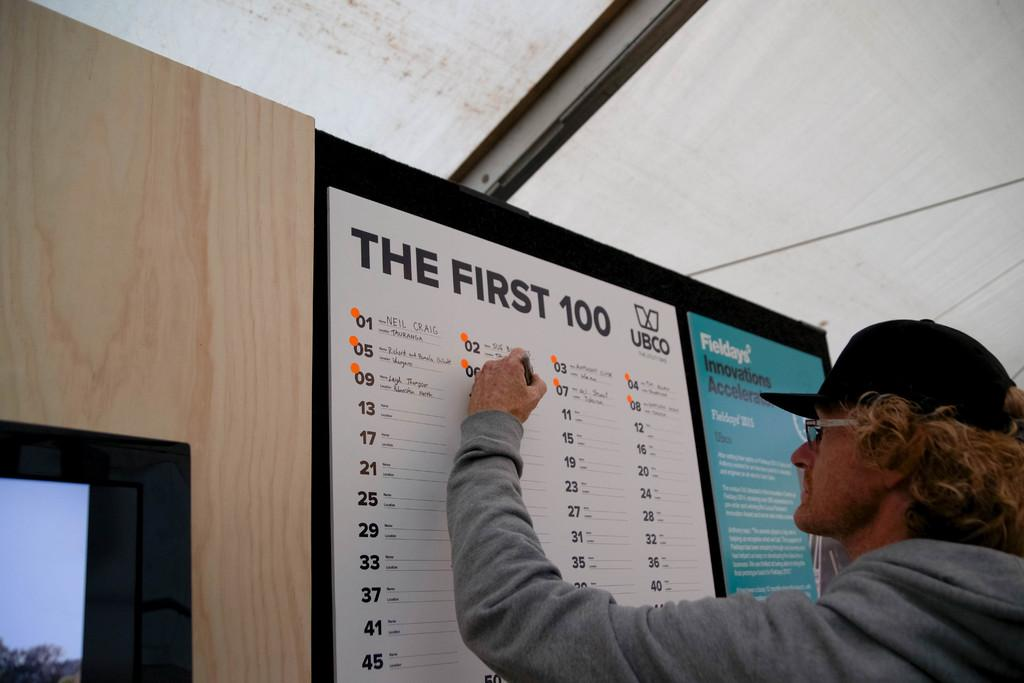<image>
Write a terse but informative summary of the picture. A man is signing his name on a chart on the wall for the first 100 UBCO, with Fieldays Innovations Accelerator on it on the right side. 